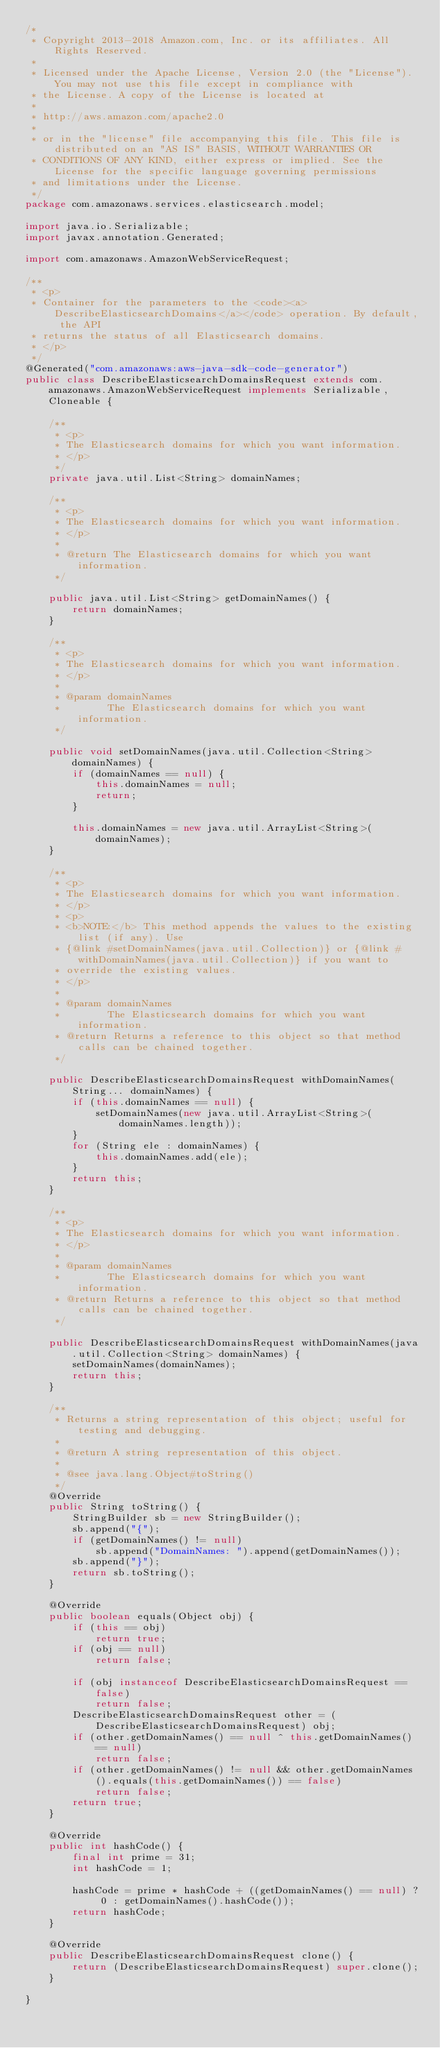<code> <loc_0><loc_0><loc_500><loc_500><_Java_>/*
 * Copyright 2013-2018 Amazon.com, Inc. or its affiliates. All Rights Reserved.
 * 
 * Licensed under the Apache License, Version 2.0 (the "License"). You may not use this file except in compliance with
 * the License. A copy of the License is located at
 * 
 * http://aws.amazon.com/apache2.0
 * 
 * or in the "license" file accompanying this file. This file is distributed on an "AS IS" BASIS, WITHOUT WARRANTIES OR
 * CONDITIONS OF ANY KIND, either express or implied. See the License for the specific language governing permissions
 * and limitations under the License.
 */
package com.amazonaws.services.elasticsearch.model;

import java.io.Serializable;
import javax.annotation.Generated;

import com.amazonaws.AmazonWebServiceRequest;

/**
 * <p>
 * Container for the parameters to the <code><a>DescribeElasticsearchDomains</a></code> operation. By default, the API
 * returns the status of all Elasticsearch domains.
 * </p>
 */
@Generated("com.amazonaws:aws-java-sdk-code-generator")
public class DescribeElasticsearchDomainsRequest extends com.amazonaws.AmazonWebServiceRequest implements Serializable, Cloneable {

    /**
     * <p>
     * The Elasticsearch domains for which you want information.
     * </p>
     */
    private java.util.List<String> domainNames;

    /**
     * <p>
     * The Elasticsearch domains for which you want information.
     * </p>
     * 
     * @return The Elasticsearch domains for which you want information.
     */

    public java.util.List<String> getDomainNames() {
        return domainNames;
    }

    /**
     * <p>
     * The Elasticsearch domains for which you want information.
     * </p>
     * 
     * @param domainNames
     *        The Elasticsearch domains for which you want information.
     */

    public void setDomainNames(java.util.Collection<String> domainNames) {
        if (domainNames == null) {
            this.domainNames = null;
            return;
        }

        this.domainNames = new java.util.ArrayList<String>(domainNames);
    }

    /**
     * <p>
     * The Elasticsearch domains for which you want information.
     * </p>
     * <p>
     * <b>NOTE:</b> This method appends the values to the existing list (if any). Use
     * {@link #setDomainNames(java.util.Collection)} or {@link #withDomainNames(java.util.Collection)} if you want to
     * override the existing values.
     * </p>
     * 
     * @param domainNames
     *        The Elasticsearch domains for which you want information.
     * @return Returns a reference to this object so that method calls can be chained together.
     */

    public DescribeElasticsearchDomainsRequest withDomainNames(String... domainNames) {
        if (this.domainNames == null) {
            setDomainNames(new java.util.ArrayList<String>(domainNames.length));
        }
        for (String ele : domainNames) {
            this.domainNames.add(ele);
        }
        return this;
    }

    /**
     * <p>
     * The Elasticsearch domains for which you want information.
     * </p>
     * 
     * @param domainNames
     *        The Elasticsearch domains for which you want information.
     * @return Returns a reference to this object so that method calls can be chained together.
     */

    public DescribeElasticsearchDomainsRequest withDomainNames(java.util.Collection<String> domainNames) {
        setDomainNames(domainNames);
        return this;
    }

    /**
     * Returns a string representation of this object; useful for testing and debugging.
     *
     * @return A string representation of this object.
     *
     * @see java.lang.Object#toString()
     */
    @Override
    public String toString() {
        StringBuilder sb = new StringBuilder();
        sb.append("{");
        if (getDomainNames() != null)
            sb.append("DomainNames: ").append(getDomainNames());
        sb.append("}");
        return sb.toString();
    }

    @Override
    public boolean equals(Object obj) {
        if (this == obj)
            return true;
        if (obj == null)
            return false;

        if (obj instanceof DescribeElasticsearchDomainsRequest == false)
            return false;
        DescribeElasticsearchDomainsRequest other = (DescribeElasticsearchDomainsRequest) obj;
        if (other.getDomainNames() == null ^ this.getDomainNames() == null)
            return false;
        if (other.getDomainNames() != null && other.getDomainNames().equals(this.getDomainNames()) == false)
            return false;
        return true;
    }

    @Override
    public int hashCode() {
        final int prime = 31;
        int hashCode = 1;

        hashCode = prime * hashCode + ((getDomainNames() == null) ? 0 : getDomainNames().hashCode());
        return hashCode;
    }

    @Override
    public DescribeElasticsearchDomainsRequest clone() {
        return (DescribeElasticsearchDomainsRequest) super.clone();
    }

}
</code> 